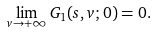Convert formula to latex. <formula><loc_0><loc_0><loc_500><loc_500>\lim _ { v \rightarrow + \infty } G _ { 1 } ( s , v ; 0 ) = 0 .</formula> 